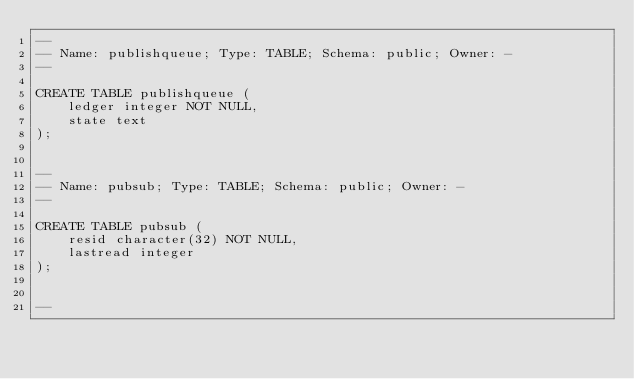<code> <loc_0><loc_0><loc_500><loc_500><_SQL_>--
-- Name: publishqueue; Type: TABLE; Schema: public; Owner: -
--

CREATE TABLE publishqueue (
    ledger integer NOT NULL,
    state text
);


--
-- Name: pubsub; Type: TABLE; Schema: public; Owner: -
--

CREATE TABLE pubsub (
    resid character(32) NOT NULL,
    lastread integer
);


--</code> 